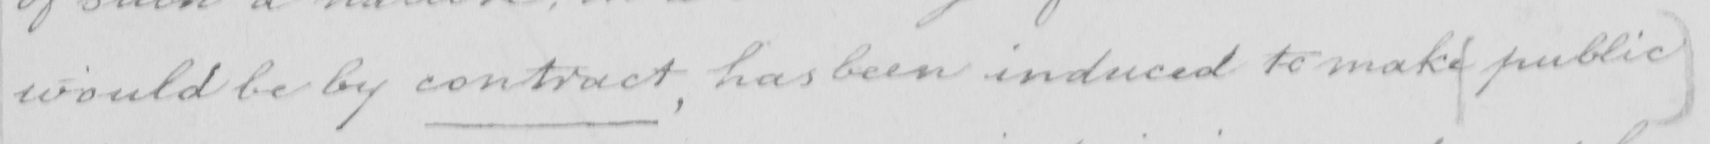Transcribe the text shown in this historical manuscript line. would be by contract , has been induced to make public 